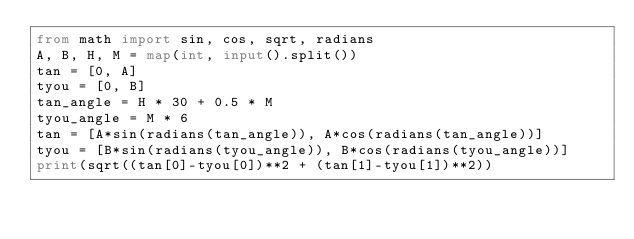<code> <loc_0><loc_0><loc_500><loc_500><_Python_>from math import sin, cos, sqrt, radians
A, B, H, M = map(int, input().split())
tan = [0, A]
tyou = [0, B]
tan_angle = H * 30 + 0.5 * M
tyou_angle = M * 6
tan = [A*sin(radians(tan_angle)), A*cos(radians(tan_angle))]
tyou = [B*sin(radians(tyou_angle)), B*cos(radians(tyou_angle))]
print(sqrt((tan[0]-tyou[0])**2 + (tan[1]-tyou[1])**2))


</code> 